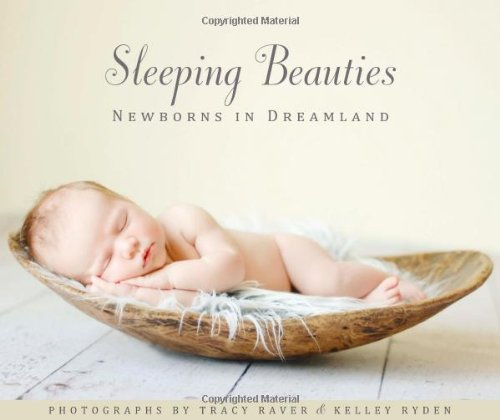What is the title of this book? The title of the book is 'Sleeping Beauties: Newborns in Dreamland,' which focuses on the serene beauty of sleeping newborns. 